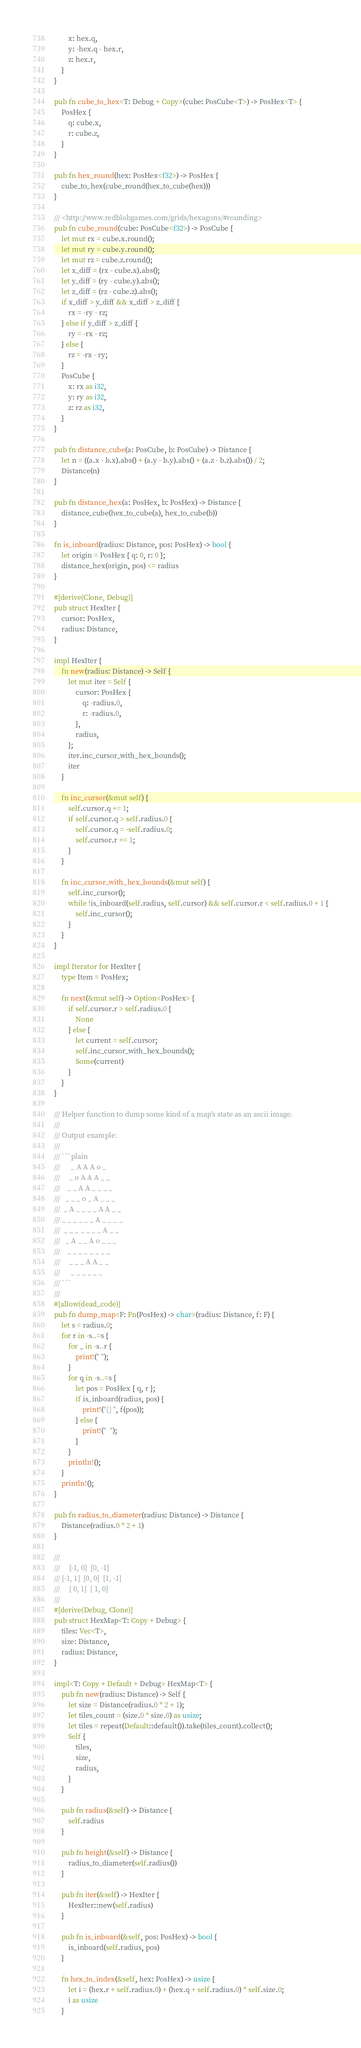<code> <loc_0><loc_0><loc_500><loc_500><_Rust_>        x: hex.q,
        y: -hex.q - hex.r,
        z: hex.r,
    }
}

pub fn cube_to_hex<T: Debug + Copy>(cube: PosCube<T>) -> PosHex<T> {
    PosHex {
        q: cube.x,
        r: cube.z,
    }
}

pub fn hex_round(hex: PosHex<f32>) -> PosHex {
    cube_to_hex(cube_round(hex_to_cube(hex)))
}

/// <http://www.redblobgames.com/grids/hexagons/#rounding>
pub fn cube_round(cube: PosCube<f32>) -> PosCube {
    let mut rx = cube.x.round();
    let mut ry = cube.y.round();
    let mut rz = cube.z.round();
    let x_diff = (rx - cube.x).abs();
    let y_diff = (ry - cube.y).abs();
    let z_diff = (rz - cube.z).abs();
    if x_diff > y_diff && x_diff > z_diff {
        rx = -ry - rz;
    } else if y_diff > z_diff {
        ry = -rx - rz;
    } else {
        rz = -rx - ry;
    }
    PosCube {
        x: rx as i32,
        y: ry as i32,
        z: rz as i32,
    }
}

pub fn distance_cube(a: PosCube, b: PosCube) -> Distance {
    let n = ((a.x - b.x).abs() + (a.y - b.y).abs() + (a.z - b.z).abs()) / 2;
    Distance(n)
}

pub fn distance_hex(a: PosHex, b: PosHex) -> Distance {
    distance_cube(hex_to_cube(a), hex_to_cube(b))
}

fn is_inboard(radius: Distance, pos: PosHex) -> bool {
    let origin = PosHex { q: 0, r: 0 };
    distance_hex(origin, pos) <= radius
}

#[derive(Clone, Debug)]
pub struct HexIter {
    cursor: PosHex,
    radius: Distance,
}

impl HexIter {
    fn new(radius: Distance) -> Self {
        let mut iter = Self {
            cursor: PosHex {
                q: -radius.0,
                r: -radius.0,
            },
            radius,
        };
        iter.inc_cursor_with_hex_bounds();
        iter
    }

    fn inc_cursor(&mut self) {
        self.cursor.q += 1;
        if self.cursor.q > self.radius.0 {
            self.cursor.q = -self.radius.0;
            self.cursor.r += 1;
        }
    }

    fn inc_cursor_with_hex_bounds(&mut self) {
        self.inc_cursor();
        while !is_inboard(self.radius, self.cursor) && self.cursor.r < self.radius.0 + 1 {
            self.inc_cursor();
        }
    }
}

impl Iterator for HexIter {
    type Item = PosHex;

    fn next(&mut self) -> Option<PosHex> {
        if self.cursor.r > self.radius.0 {
            None
        } else {
            let current = self.cursor;
            self.inc_cursor_with_hex_bounds();
            Some(current)
        }
    }
}

/// Helper function to dump some kind of a map's state as an ascii image.
///
/// Output example:
///
/// ```plain
///      _ A A A o _
///     _ o A A A _ _
///    _ _ A A _ _ _ _
///   _ _ _ o _ A _ _ _
///  _ A _ _ _ _ A A _ _
/// _ _ _ _ _ _ A _ _ _ _
///  _ _ _ _ _ _ _ A _ _
///   _ A _ _ A o _ _ _
///    _ _ _ _ _ _ _ _
///     _ _ _ A A _ _
///      _ _ _ _ _ _
/// ```
///
#[allow(dead_code)]
pub fn dump_map<F: Fn(PosHex) -> char>(radius: Distance, f: F) {
    let s = radius.0;
    for r in -s..=s {
        for _ in -s..r {
            print!(" ");
        }
        for q in -s..=s {
            let pos = PosHex { q, r };
            if is_inboard(radius, pos) {
                print!("{} ", f(pos));
            } else {
                print!("  ");
            }
        }
        println!();
    }
    println!();
}

pub fn radius_to_diameter(radius: Distance) -> Distance {
    Distance(radius.0 * 2 + 1)
}

///
///     [-1, 0]  [0, -1]
/// [-1, 1]  [0, 0]  [1, -1]
///     [ 0, 1]  [ 1, 0]
///
#[derive(Debug, Clone)]
pub struct HexMap<T: Copy + Debug> {
    tiles: Vec<T>,
    size: Distance,
    radius: Distance,
}

impl<T: Copy + Default + Debug> HexMap<T> {
    pub fn new(radius: Distance) -> Self {
        let size = Distance(radius.0 * 2 + 1);
        let tiles_count = (size.0 * size.0) as usize;
        let tiles = repeat(Default::default()).take(tiles_count).collect();
        Self {
            tiles,
            size,
            radius,
        }
    }

    pub fn radius(&self) -> Distance {
        self.radius
    }

    pub fn height(&self) -> Distance {
        radius_to_diameter(self.radius())
    }

    pub fn iter(&self) -> HexIter {
        HexIter::new(self.radius)
    }

    pub fn is_inboard(&self, pos: PosHex) -> bool {
        is_inboard(self.radius, pos)
    }

    fn hex_to_index(&self, hex: PosHex) -> usize {
        let i = (hex.r + self.radius.0) + (hex.q + self.radius.0) * self.size.0;
        i as usize
    }
</code> 